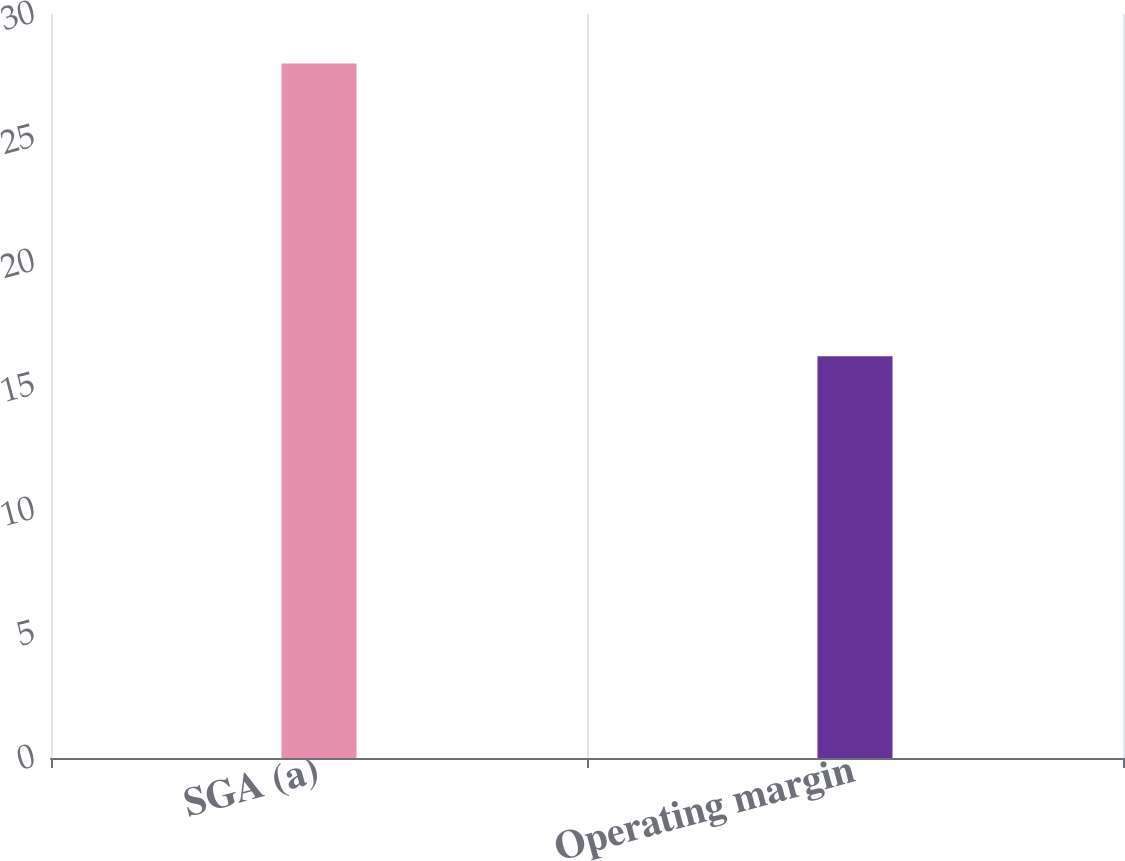Convert chart to OTSL. <chart><loc_0><loc_0><loc_500><loc_500><bar_chart><fcel>SGA (a)<fcel>Operating margin<nl><fcel>28<fcel>16.2<nl></chart> 